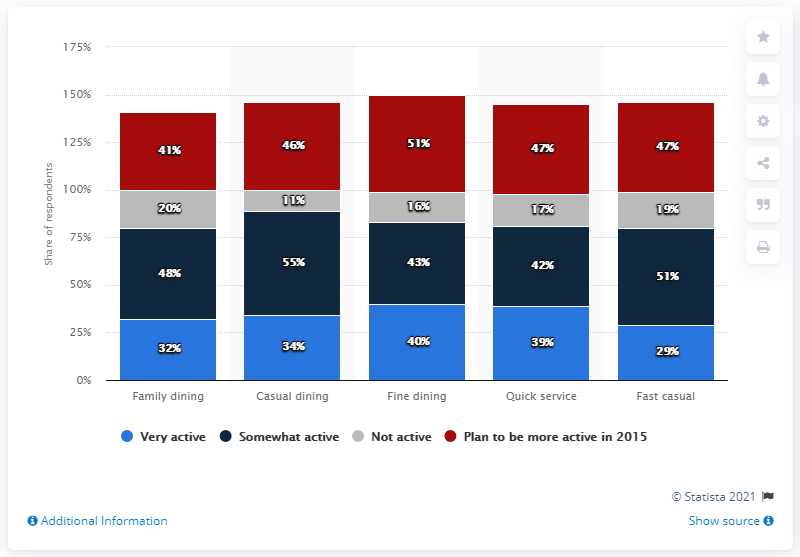Draw attention to some important aspects in this diagram. The sum of the highest and lowest values of the light blue bar is 69. The lowest value in the blue bar is 29. 